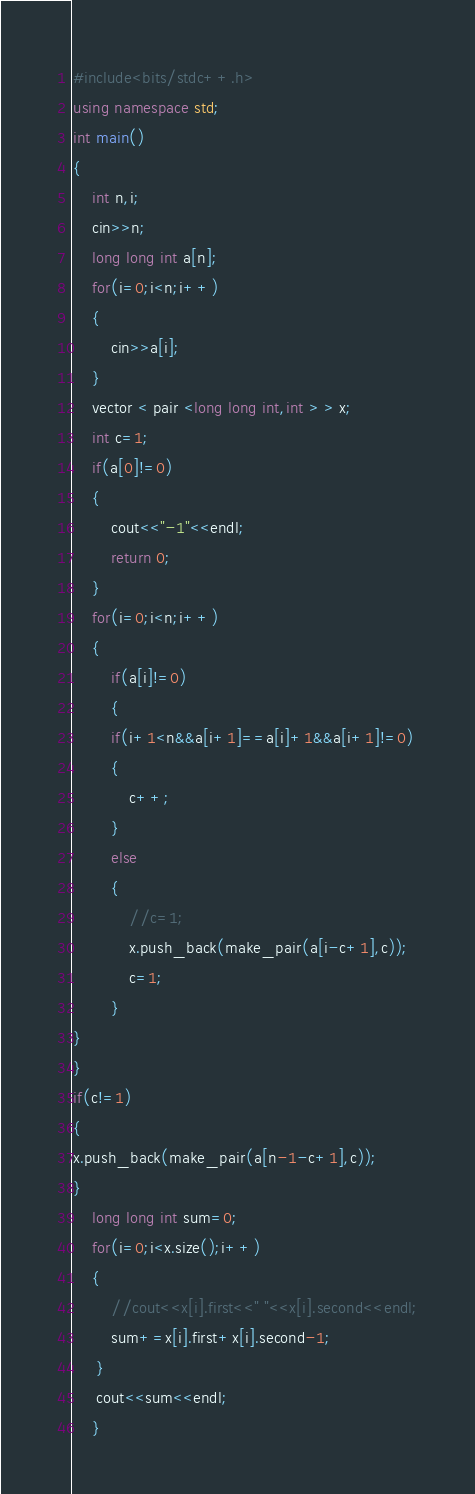Convert code to text. <code><loc_0><loc_0><loc_500><loc_500><_C++_>#include<bits/stdc++.h>
using namespace std;
int main()
{
	int n,i;
	cin>>n;
	long long int a[n];
	for(i=0;i<n;i++)
	{
		cin>>a[i];
	}
	vector < pair <long long int,int > > x;
	int c=1;
	if(a[0]!=0)
	{
		cout<<"-1"<<endl;
		return 0;
	}
	for(i=0;i<n;i++)
	{
		if(a[i]!=0)
		{
		if(i+1<n&&a[i+1]==a[i]+1&&a[i+1]!=0)
		{
			c++;
		}
		else
		{
			//c=1;
			x.push_back(make_pair(a[i-c+1],c));
			c=1;
		}
}
}
if(c!=1)
{
x.push_back(make_pair(a[n-1-c+1],c));	
}
	long long int sum=0;
	for(i=0;i<x.size();i++)
	{
		//cout<<x[i].first<<" "<<x[i].second<<endl;
		sum+=x[i].first+x[i].second-1;
	 }
	 cout<<sum<<endl; 
	}</code> 